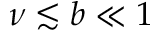<formula> <loc_0><loc_0><loc_500><loc_500>\nu \lesssim b \ll 1</formula> 